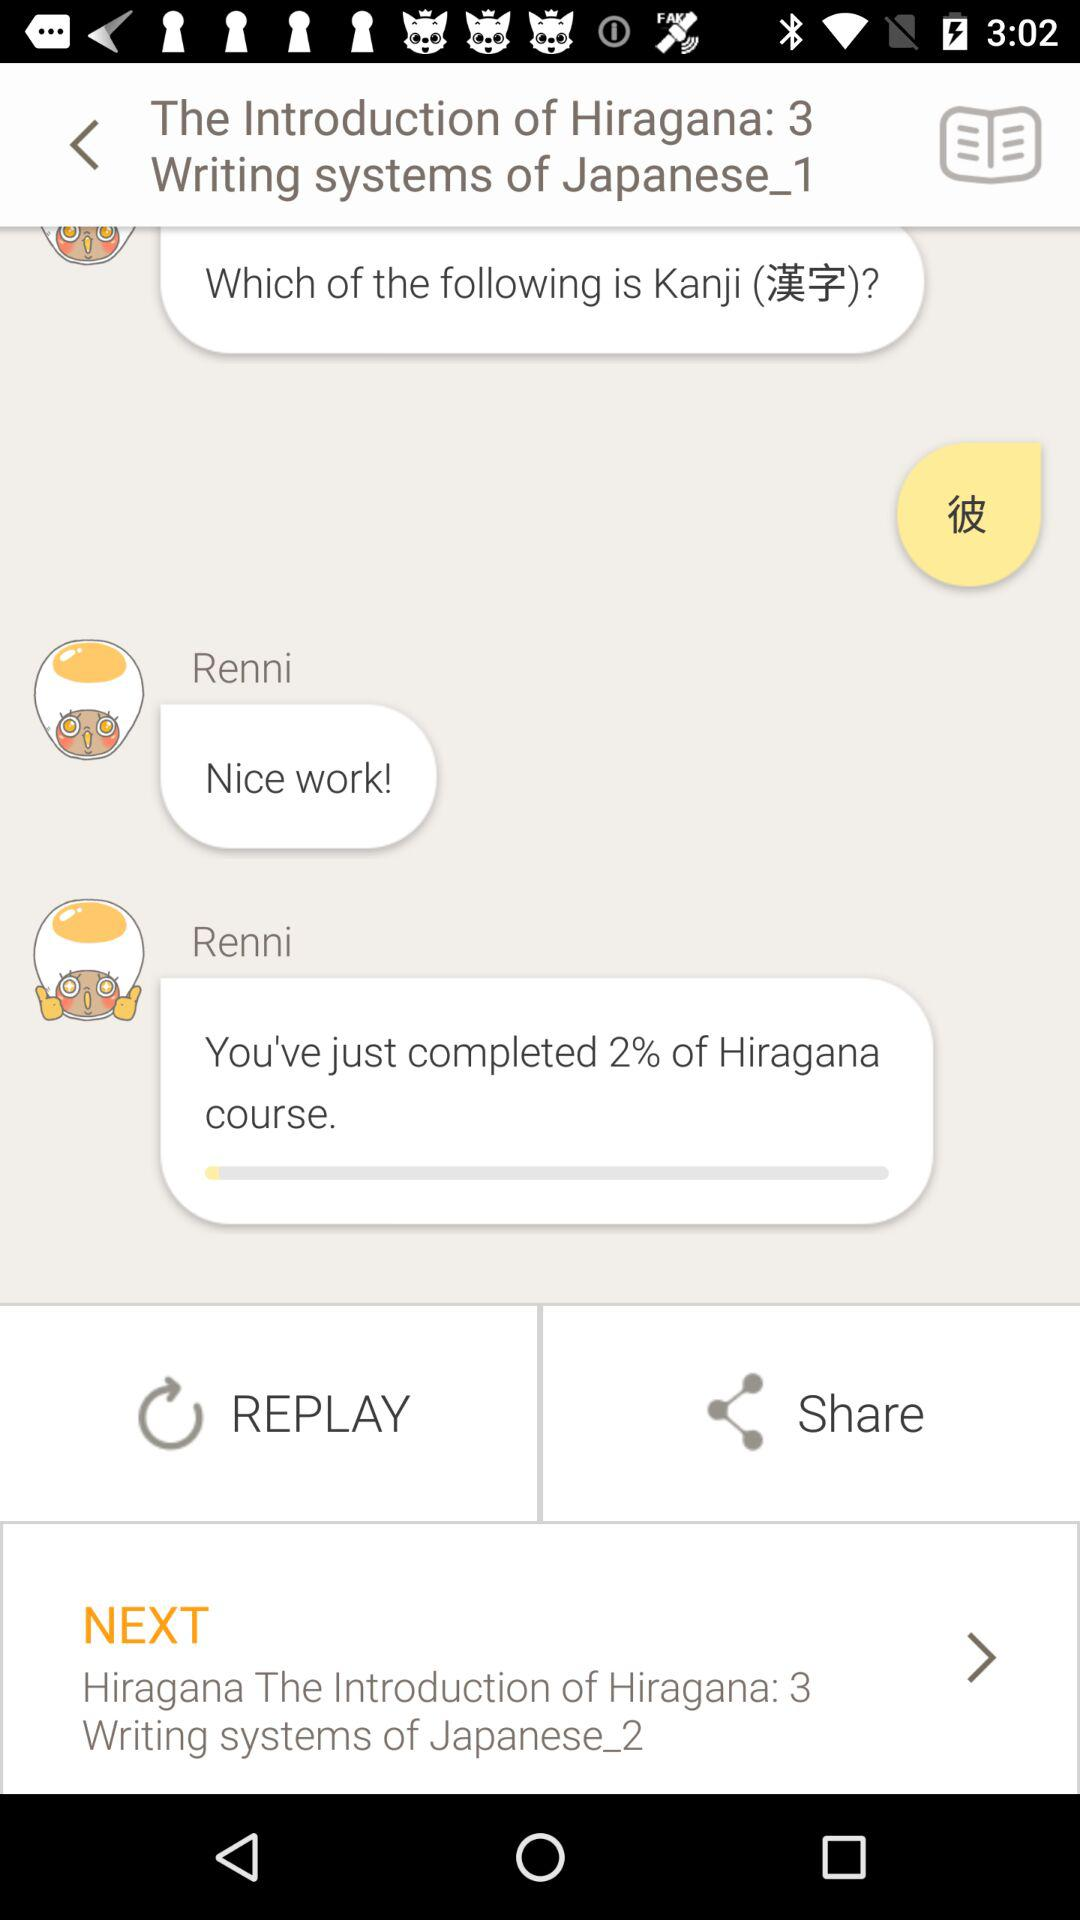What percentage of the course has Renni completed?
Answer the question using a single word or phrase. 2% 